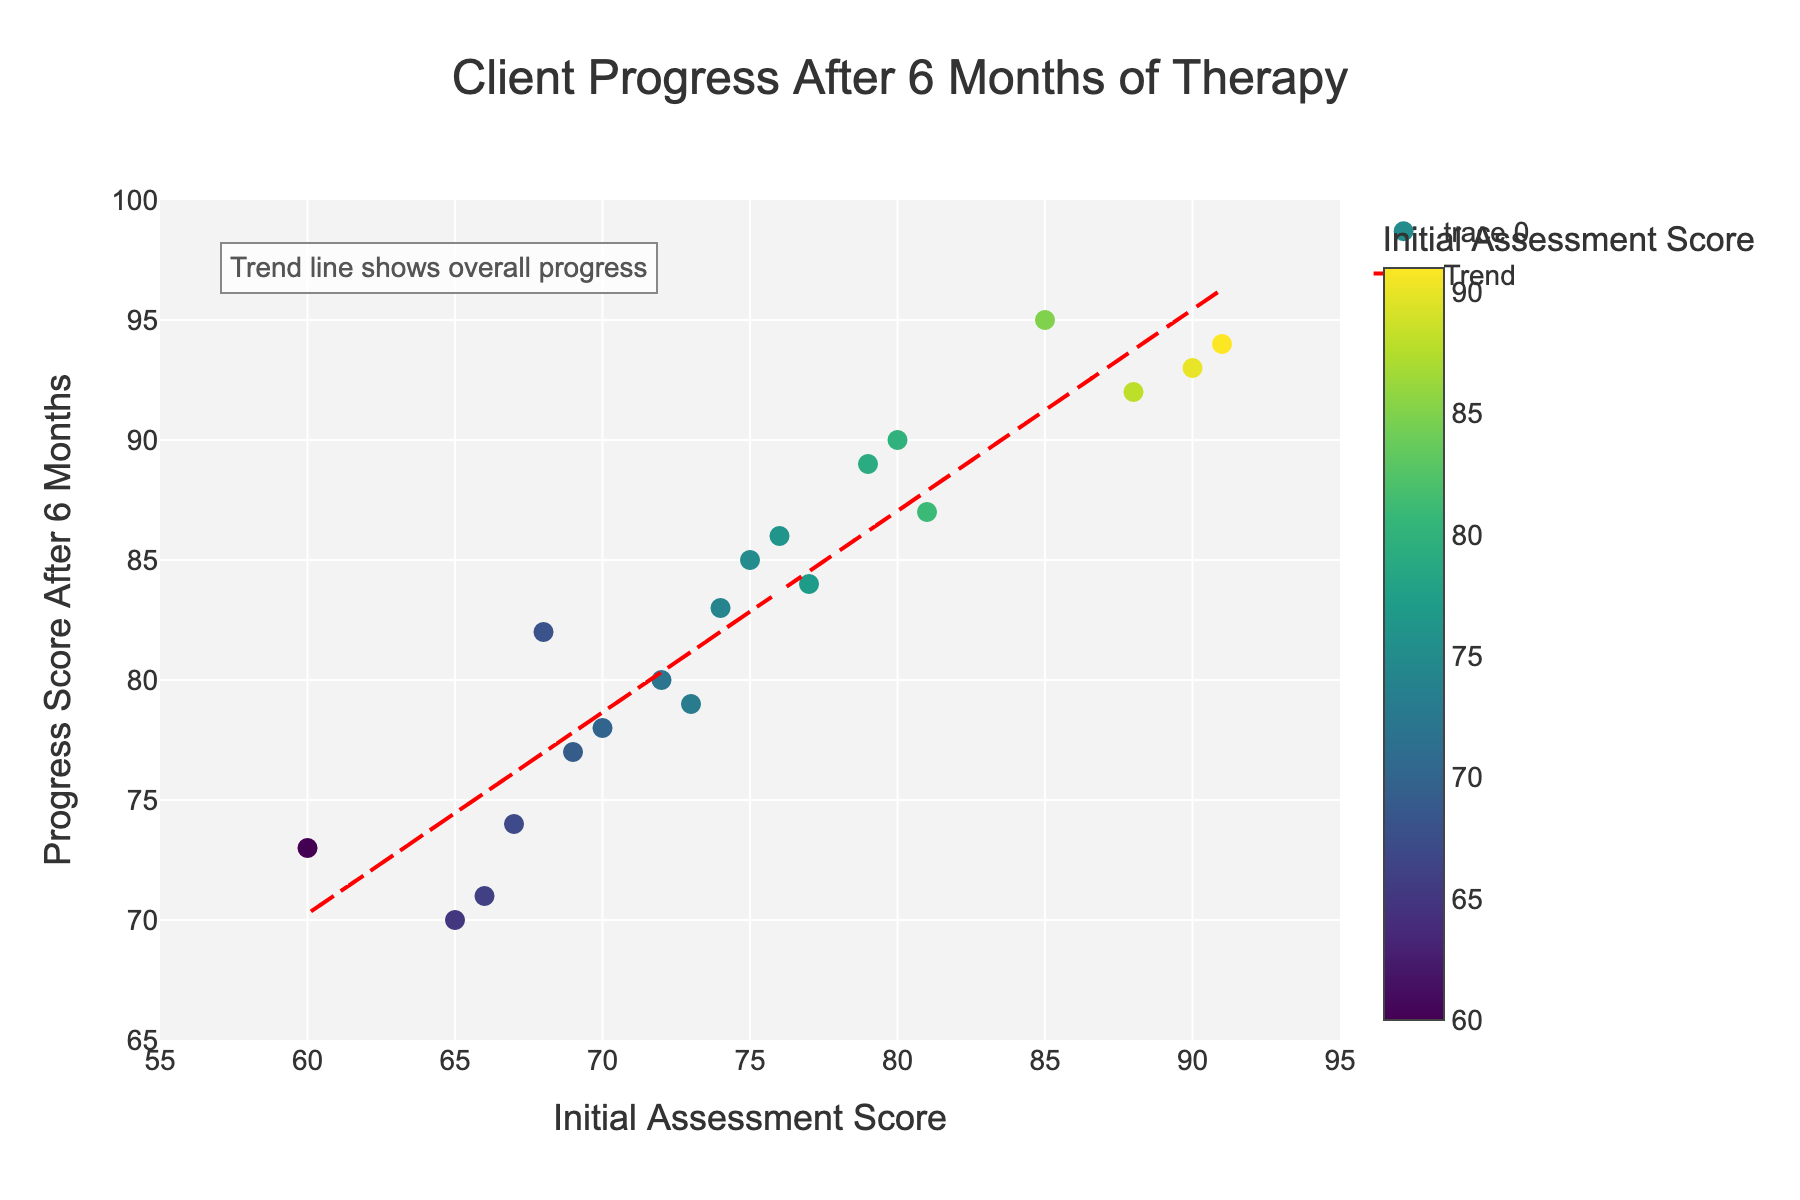What is the title of the scatter plot? The title of the scatter plot is usually found at the top center of the figure. In this case, it reads 'Client Progress After 6 Months of Therapy'.
Answer: Client Progress After 6 Months of Therapy What are the axis titles? The axis titles are generally found along the axes of the plot. The x-axis title is 'Initial Assessment Score', and the y-axis title is 'Progress Score After 6 Months'.
Answer: Initial Assessment Score, Progress Score After 6 Months How many data points are shown in the scatter plot? Each client's progress is represented by a single point on the scatter plot. By counting each unique data point on the plot, we find there are 20 points.
Answer: 20 Which client has the highest initial assessment score, and what is their progress score after 6 months? To find this, look for the data point with the highest x-axis value. The client with the highest initial score is Client C019, and their progress score after 6 months is 94.
Answer: C019, 94 Is there a general trend in the data, and how is it represented on the scatter plot? A general trend can be represented by a trend line in a scatter plot. In this figure, the red dashed line shows the upward trend, indicating that higher initial assessment scores tend to correlate with higher progress scores after 6 months.
Answer: Yes, shown by the red dashed trend line What is the initial assessment score and progress score for Client C007? Identify the marker tagged with Client C007. From the hover information or by tracing the point, Client C007 has an initial assessment score of 90 and a progress score of 93.
Answer: 90, 93 Are there any clients whose progress score after 6 months did not improve by at least 5 points from their initial assessment score? By examining the plot, look for points where the difference between the x and y values is less than 5. Clients C009 and C018 fit this criterion with progress scores of 70 and 71 respectively, improved by only 5 points or less.
Answer: C009, C018 What is the range of initial assessment scores shown on the x-axis? The range on the x-axis can be determined from the axis limits, which are set from 55 to 95.
Answer: 55 to 95 Which clients improved the most over the 6 months, and by how many points did they improve? To find this, identify the data point with the largest vertical difference between y and x values. Client C005 improved the most with an increase from 85 to 95, which is a 10-point improvement.
Answer: C005, 10 points 